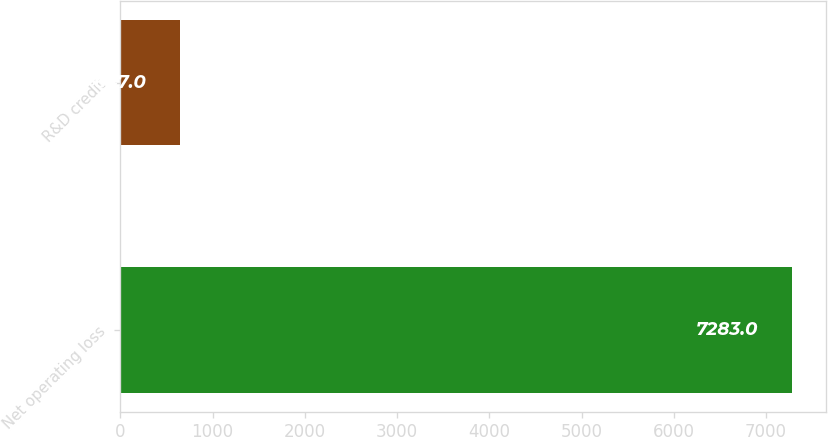Convert chart to OTSL. <chart><loc_0><loc_0><loc_500><loc_500><bar_chart><fcel>Net operating loss<fcel>R&D credit<nl><fcel>7283<fcel>647<nl></chart> 